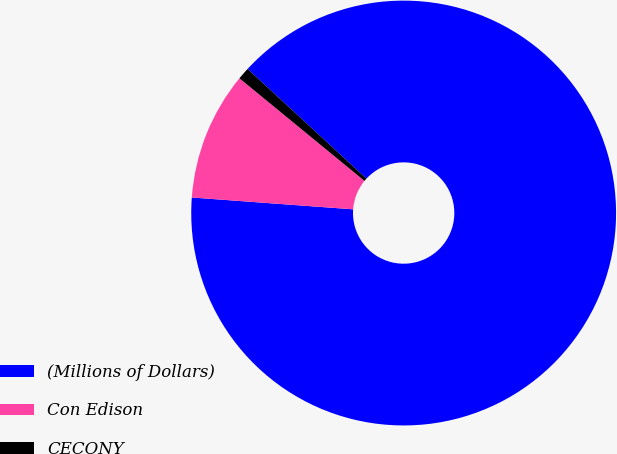Convert chart to OTSL. <chart><loc_0><loc_0><loc_500><loc_500><pie_chart><fcel>(Millions of Dollars)<fcel>Con Edison<fcel>CECONY<nl><fcel>89.3%<fcel>9.77%<fcel>0.93%<nl></chart> 